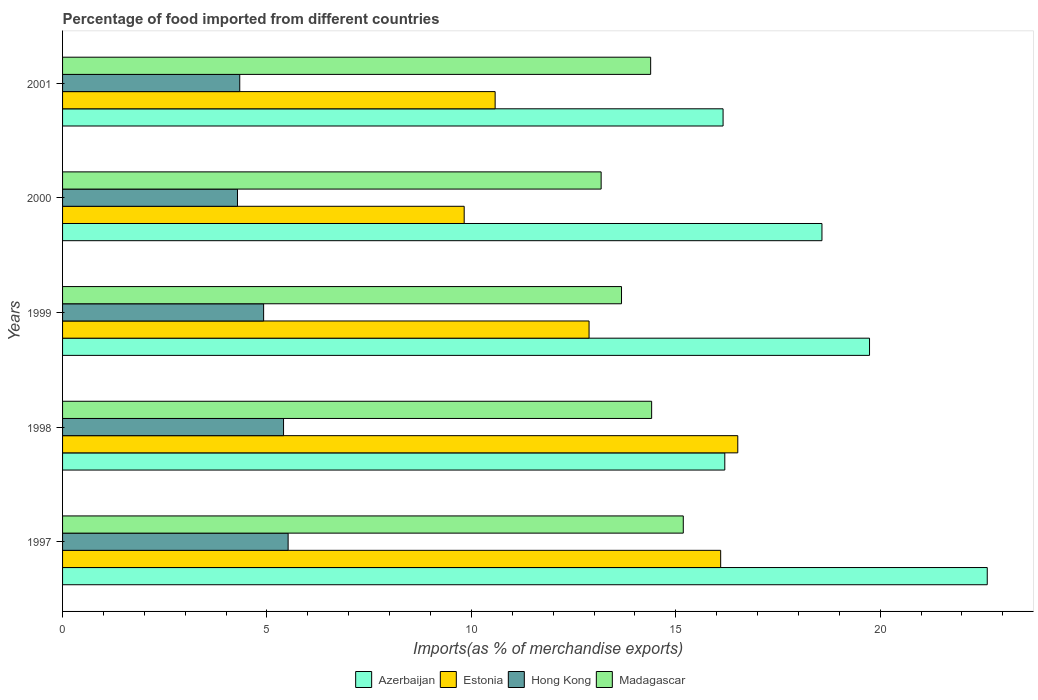How many different coloured bars are there?
Provide a succinct answer. 4. Are the number of bars per tick equal to the number of legend labels?
Give a very brief answer. Yes. Are the number of bars on each tick of the Y-axis equal?
Provide a short and direct response. Yes. How many bars are there on the 5th tick from the bottom?
Provide a succinct answer. 4. What is the label of the 3rd group of bars from the top?
Make the answer very short. 1999. In how many cases, is the number of bars for a given year not equal to the number of legend labels?
Ensure brevity in your answer.  0. What is the percentage of imports to different countries in Hong Kong in 2001?
Ensure brevity in your answer.  4.33. Across all years, what is the maximum percentage of imports to different countries in Estonia?
Offer a very short reply. 16.52. Across all years, what is the minimum percentage of imports to different countries in Madagascar?
Ensure brevity in your answer.  13.17. In which year was the percentage of imports to different countries in Madagascar minimum?
Provide a short and direct response. 2000. What is the total percentage of imports to different countries in Estonia in the graph?
Provide a short and direct response. 65.9. What is the difference between the percentage of imports to different countries in Madagascar in 2000 and that in 2001?
Make the answer very short. -1.21. What is the difference between the percentage of imports to different countries in Estonia in 2000 and the percentage of imports to different countries in Madagascar in 1998?
Offer a terse response. -4.59. What is the average percentage of imports to different countries in Hong Kong per year?
Make the answer very short. 4.89. In the year 1997, what is the difference between the percentage of imports to different countries in Madagascar and percentage of imports to different countries in Estonia?
Your response must be concise. -0.91. What is the ratio of the percentage of imports to different countries in Hong Kong in 1997 to that in 2000?
Ensure brevity in your answer.  1.29. Is the percentage of imports to different countries in Hong Kong in 1998 less than that in 2001?
Provide a short and direct response. No. What is the difference between the highest and the second highest percentage of imports to different countries in Estonia?
Give a very brief answer. 0.42. What is the difference between the highest and the lowest percentage of imports to different countries in Azerbaijan?
Provide a succinct answer. 6.46. In how many years, is the percentage of imports to different countries in Madagascar greater than the average percentage of imports to different countries in Madagascar taken over all years?
Offer a terse response. 3. Is the sum of the percentage of imports to different countries in Estonia in 1998 and 1999 greater than the maximum percentage of imports to different countries in Madagascar across all years?
Ensure brevity in your answer.  Yes. What does the 2nd bar from the top in 2001 represents?
Provide a short and direct response. Hong Kong. What does the 2nd bar from the bottom in 1998 represents?
Offer a very short reply. Estonia. Are the values on the major ticks of X-axis written in scientific E-notation?
Provide a succinct answer. No. Where does the legend appear in the graph?
Your answer should be very brief. Bottom center. What is the title of the graph?
Your response must be concise. Percentage of food imported from different countries. Does "Malta" appear as one of the legend labels in the graph?
Offer a terse response. No. What is the label or title of the X-axis?
Your answer should be compact. Imports(as % of merchandise exports). What is the label or title of the Y-axis?
Provide a short and direct response. Years. What is the Imports(as % of merchandise exports) in Azerbaijan in 1997?
Ensure brevity in your answer.  22.62. What is the Imports(as % of merchandise exports) of Estonia in 1997?
Your response must be concise. 16.1. What is the Imports(as % of merchandise exports) of Hong Kong in 1997?
Ensure brevity in your answer.  5.52. What is the Imports(as % of merchandise exports) of Madagascar in 1997?
Make the answer very short. 15.18. What is the Imports(as % of merchandise exports) in Azerbaijan in 1998?
Make the answer very short. 16.2. What is the Imports(as % of merchandise exports) of Estonia in 1998?
Provide a succinct answer. 16.52. What is the Imports(as % of merchandise exports) of Hong Kong in 1998?
Your answer should be compact. 5.41. What is the Imports(as % of merchandise exports) of Madagascar in 1998?
Make the answer very short. 14.41. What is the Imports(as % of merchandise exports) in Azerbaijan in 1999?
Ensure brevity in your answer.  19.74. What is the Imports(as % of merchandise exports) in Estonia in 1999?
Provide a succinct answer. 12.88. What is the Imports(as % of merchandise exports) in Hong Kong in 1999?
Ensure brevity in your answer.  4.92. What is the Imports(as % of merchandise exports) in Madagascar in 1999?
Provide a succinct answer. 13.67. What is the Imports(as % of merchandise exports) of Azerbaijan in 2000?
Your answer should be very brief. 18.58. What is the Imports(as % of merchandise exports) of Estonia in 2000?
Provide a succinct answer. 9.82. What is the Imports(as % of merchandise exports) in Hong Kong in 2000?
Make the answer very short. 4.28. What is the Imports(as % of merchandise exports) of Madagascar in 2000?
Provide a short and direct response. 13.17. What is the Imports(as % of merchandise exports) in Azerbaijan in 2001?
Keep it short and to the point. 16.16. What is the Imports(as % of merchandise exports) in Estonia in 2001?
Provide a succinct answer. 10.58. What is the Imports(as % of merchandise exports) in Hong Kong in 2001?
Provide a short and direct response. 4.33. What is the Imports(as % of merchandise exports) of Madagascar in 2001?
Provide a short and direct response. 14.39. Across all years, what is the maximum Imports(as % of merchandise exports) of Azerbaijan?
Your response must be concise. 22.62. Across all years, what is the maximum Imports(as % of merchandise exports) in Estonia?
Provide a succinct answer. 16.52. Across all years, what is the maximum Imports(as % of merchandise exports) of Hong Kong?
Offer a very short reply. 5.52. Across all years, what is the maximum Imports(as % of merchandise exports) in Madagascar?
Your response must be concise. 15.18. Across all years, what is the minimum Imports(as % of merchandise exports) in Azerbaijan?
Ensure brevity in your answer.  16.16. Across all years, what is the minimum Imports(as % of merchandise exports) of Estonia?
Offer a very short reply. 9.82. Across all years, what is the minimum Imports(as % of merchandise exports) of Hong Kong?
Offer a terse response. 4.28. Across all years, what is the minimum Imports(as % of merchandise exports) of Madagascar?
Provide a succinct answer. 13.17. What is the total Imports(as % of merchandise exports) of Azerbaijan in the graph?
Your answer should be compact. 93.29. What is the total Imports(as % of merchandise exports) of Estonia in the graph?
Offer a very short reply. 65.9. What is the total Imports(as % of merchandise exports) in Hong Kong in the graph?
Ensure brevity in your answer.  24.45. What is the total Imports(as % of merchandise exports) in Madagascar in the graph?
Your answer should be very brief. 70.83. What is the difference between the Imports(as % of merchandise exports) in Azerbaijan in 1997 and that in 1998?
Provide a succinct answer. 6.42. What is the difference between the Imports(as % of merchandise exports) in Estonia in 1997 and that in 1998?
Give a very brief answer. -0.42. What is the difference between the Imports(as % of merchandise exports) of Hong Kong in 1997 and that in 1998?
Ensure brevity in your answer.  0.11. What is the difference between the Imports(as % of merchandise exports) of Madagascar in 1997 and that in 1998?
Ensure brevity in your answer.  0.77. What is the difference between the Imports(as % of merchandise exports) in Azerbaijan in 1997 and that in 1999?
Your answer should be compact. 2.88. What is the difference between the Imports(as % of merchandise exports) in Estonia in 1997 and that in 1999?
Give a very brief answer. 3.22. What is the difference between the Imports(as % of merchandise exports) in Hong Kong in 1997 and that in 1999?
Your answer should be very brief. 0.6. What is the difference between the Imports(as % of merchandise exports) of Madagascar in 1997 and that in 1999?
Provide a short and direct response. 1.51. What is the difference between the Imports(as % of merchandise exports) of Azerbaijan in 1997 and that in 2000?
Provide a succinct answer. 4.04. What is the difference between the Imports(as % of merchandise exports) in Estonia in 1997 and that in 2000?
Your answer should be compact. 6.27. What is the difference between the Imports(as % of merchandise exports) of Hong Kong in 1997 and that in 2000?
Keep it short and to the point. 1.24. What is the difference between the Imports(as % of merchandise exports) in Madagascar in 1997 and that in 2000?
Offer a terse response. 2.01. What is the difference between the Imports(as % of merchandise exports) in Azerbaijan in 1997 and that in 2001?
Your response must be concise. 6.46. What is the difference between the Imports(as % of merchandise exports) in Estonia in 1997 and that in 2001?
Your response must be concise. 5.52. What is the difference between the Imports(as % of merchandise exports) in Hong Kong in 1997 and that in 2001?
Offer a very short reply. 1.18. What is the difference between the Imports(as % of merchandise exports) in Madagascar in 1997 and that in 2001?
Your response must be concise. 0.8. What is the difference between the Imports(as % of merchandise exports) of Azerbaijan in 1998 and that in 1999?
Provide a short and direct response. -3.54. What is the difference between the Imports(as % of merchandise exports) of Estonia in 1998 and that in 1999?
Your answer should be compact. 3.64. What is the difference between the Imports(as % of merchandise exports) in Hong Kong in 1998 and that in 1999?
Provide a short and direct response. 0.49. What is the difference between the Imports(as % of merchandise exports) of Madagascar in 1998 and that in 1999?
Make the answer very short. 0.74. What is the difference between the Imports(as % of merchandise exports) of Azerbaijan in 1998 and that in 2000?
Keep it short and to the point. -2.38. What is the difference between the Imports(as % of merchandise exports) in Estonia in 1998 and that in 2000?
Your answer should be compact. 6.69. What is the difference between the Imports(as % of merchandise exports) of Hong Kong in 1998 and that in 2000?
Your answer should be compact. 1.13. What is the difference between the Imports(as % of merchandise exports) of Madagascar in 1998 and that in 2000?
Offer a very short reply. 1.24. What is the difference between the Imports(as % of merchandise exports) in Azerbaijan in 1998 and that in 2001?
Your answer should be very brief. 0.04. What is the difference between the Imports(as % of merchandise exports) in Estonia in 1998 and that in 2001?
Provide a short and direct response. 5.94. What is the difference between the Imports(as % of merchandise exports) in Hong Kong in 1998 and that in 2001?
Your answer should be very brief. 1.07. What is the difference between the Imports(as % of merchandise exports) in Madagascar in 1998 and that in 2001?
Provide a short and direct response. 0.02. What is the difference between the Imports(as % of merchandise exports) in Azerbaijan in 1999 and that in 2000?
Provide a succinct answer. 1.16. What is the difference between the Imports(as % of merchandise exports) of Estonia in 1999 and that in 2000?
Your answer should be very brief. 3.05. What is the difference between the Imports(as % of merchandise exports) of Hong Kong in 1999 and that in 2000?
Provide a short and direct response. 0.64. What is the difference between the Imports(as % of merchandise exports) of Madagascar in 1999 and that in 2000?
Offer a very short reply. 0.5. What is the difference between the Imports(as % of merchandise exports) in Azerbaijan in 1999 and that in 2001?
Ensure brevity in your answer.  3.58. What is the difference between the Imports(as % of merchandise exports) of Estonia in 1999 and that in 2001?
Keep it short and to the point. 2.3. What is the difference between the Imports(as % of merchandise exports) in Hong Kong in 1999 and that in 2001?
Give a very brief answer. 0.58. What is the difference between the Imports(as % of merchandise exports) of Madagascar in 1999 and that in 2001?
Keep it short and to the point. -0.71. What is the difference between the Imports(as % of merchandise exports) of Azerbaijan in 2000 and that in 2001?
Your answer should be very brief. 2.42. What is the difference between the Imports(as % of merchandise exports) of Estonia in 2000 and that in 2001?
Ensure brevity in your answer.  -0.76. What is the difference between the Imports(as % of merchandise exports) in Hong Kong in 2000 and that in 2001?
Ensure brevity in your answer.  -0.06. What is the difference between the Imports(as % of merchandise exports) of Madagascar in 2000 and that in 2001?
Offer a very short reply. -1.21. What is the difference between the Imports(as % of merchandise exports) in Azerbaijan in 1997 and the Imports(as % of merchandise exports) in Estonia in 1998?
Provide a succinct answer. 6.1. What is the difference between the Imports(as % of merchandise exports) in Azerbaijan in 1997 and the Imports(as % of merchandise exports) in Hong Kong in 1998?
Offer a terse response. 17.21. What is the difference between the Imports(as % of merchandise exports) in Azerbaijan in 1997 and the Imports(as % of merchandise exports) in Madagascar in 1998?
Give a very brief answer. 8.21. What is the difference between the Imports(as % of merchandise exports) of Estonia in 1997 and the Imports(as % of merchandise exports) of Hong Kong in 1998?
Give a very brief answer. 10.69. What is the difference between the Imports(as % of merchandise exports) of Estonia in 1997 and the Imports(as % of merchandise exports) of Madagascar in 1998?
Offer a terse response. 1.69. What is the difference between the Imports(as % of merchandise exports) of Hong Kong in 1997 and the Imports(as % of merchandise exports) of Madagascar in 1998?
Provide a short and direct response. -8.89. What is the difference between the Imports(as % of merchandise exports) in Azerbaijan in 1997 and the Imports(as % of merchandise exports) in Estonia in 1999?
Your answer should be compact. 9.74. What is the difference between the Imports(as % of merchandise exports) of Azerbaijan in 1997 and the Imports(as % of merchandise exports) of Hong Kong in 1999?
Keep it short and to the point. 17.7. What is the difference between the Imports(as % of merchandise exports) of Azerbaijan in 1997 and the Imports(as % of merchandise exports) of Madagascar in 1999?
Give a very brief answer. 8.95. What is the difference between the Imports(as % of merchandise exports) in Estonia in 1997 and the Imports(as % of merchandise exports) in Hong Kong in 1999?
Offer a terse response. 11.18. What is the difference between the Imports(as % of merchandise exports) in Estonia in 1997 and the Imports(as % of merchandise exports) in Madagascar in 1999?
Your response must be concise. 2.43. What is the difference between the Imports(as % of merchandise exports) of Hong Kong in 1997 and the Imports(as % of merchandise exports) of Madagascar in 1999?
Your answer should be very brief. -8.16. What is the difference between the Imports(as % of merchandise exports) of Azerbaijan in 1997 and the Imports(as % of merchandise exports) of Estonia in 2000?
Your response must be concise. 12.8. What is the difference between the Imports(as % of merchandise exports) in Azerbaijan in 1997 and the Imports(as % of merchandise exports) in Hong Kong in 2000?
Your response must be concise. 18.34. What is the difference between the Imports(as % of merchandise exports) of Azerbaijan in 1997 and the Imports(as % of merchandise exports) of Madagascar in 2000?
Provide a short and direct response. 9.45. What is the difference between the Imports(as % of merchandise exports) of Estonia in 1997 and the Imports(as % of merchandise exports) of Hong Kong in 2000?
Your answer should be compact. 11.82. What is the difference between the Imports(as % of merchandise exports) in Estonia in 1997 and the Imports(as % of merchandise exports) in Madagascar in 2000?
Provide a short and direct response. 2.92. What is the difference between the Imports(as % of merchandise exports) in Hong Kong in 1997 and the Imports(as % of merchandise exports) in Madagascar in 2000?
Ensure brevity in your answer.  -7.66. What is the difference between the Imports(as % of merchandise exports) in Azerbaijan in 1997 and the Imports(as % of merchandise exports) in Estonia in 2001?
Keep it short and to the point. 12.04. What is the difference between the Imports(as % of merchandise exports) in Azerbaijan in 1997 and the Imports(as % of merchandise exports) in Hong Kong in 2001?
Your answer should be very brief. 18.29. What is the difference between the Imports(as % of merchandise exports) of Azerbaijan in 1997 and the Imports(as % of merchandise exports) of Madagascar in 2001?
Provide a succinct answer. 8.23. What is the difference between the Imports(as % of merchandise exports) of Estonia in 1997 and the Imports(as % of merchandise exports) of Hong Kong in 2001?
Provide a succinct answer. 11.76. What is the difference between the Imports(as % of merchandise exports) in Estonia in 1997 and the Imports(as % of merchandise exports) in Madagascar in 2001?
Your response must be concise. 1.71. What is the difference between the Imports(as % of merchandise exports) in Hong Kong in 1997 and the Imports(as % of merchandise exports) in Madagascar in 2001?
Provide a succinct answer. -8.87. What is the difference between the Imports(as % of merchandise exports) in Azerbaijan in 1998 and the Imports(as % of merchandise exports) in Estonia in 1999?
Ensure brevity in your answer.  3.32. What is the difference between the Imports(as % of merchandise exports) of Azerbaijan in 1998 and the Imports(as % of merchandise exports) of Hong Kong in 1999?
Ensure brevity in your answer.  11.28. What is the difference between the Imports(as % of merchandise exports) in Azerbaijan in 1998 and the Imports(as % of merchandise exports) in Madagascar in 1999?
Ensure brevity in your answer.  2.53. What is the difference between the Imports(as % of merchandise exports) of Estonia in 1998 and the Imports(as % of merchandise exports) of Hong Kong in 1999?
Offer a very short reply. 11.6. What is the difference between the Imports(as % of merchandise exports) of Estonia in 1998 and the Imports(as % of merchandise exports) of Madagascar in 1999?
Keep it short and to the point. 2.84. What is the difference between the Imports(as % of merchandise exports) in Hong Kong in 1998 and the Imports(as % of merchandise exports) in Madagascar in 1999?
Provide a succinct answer. -8.27. What is the difference between the Imports(as % of merchandise exports) of Azerbaijan in 1998 and the Imports(as % of merchandise exports) of Estonia in 2000?
Offer a terse response. 6.37. What is the difference between the Imports(as % of merchandise exports) of Azerbaijan in 1998 and the Imports(as % of merchandise exports) of Hong Kong in 2000?
Provide a succinct answer. 11.92. What is the difference between the Imports(as % of merchandise exports) of Azerbaijan in 1998 and the Imports(as % of merchandise exports) of Madagascar in 2000?
Offer a very short reply. 3.02. What is the difference between the Imports(as % of merchandise exports) in Estonia in 1998 and the Imports(as % of merchandise exports) in Hong Kong in 2000?
Keep it short and to the point. 12.24. What is the difference between the Imports(as % of merchandise exports) in Estonia in 1998 and the Imports(as % of merchandise exports) in Madagascar in 2000?
Keep it short and to the point. 3.34. What is the difference between the Imports(as % of merchandise exports) in Hong Kong in 1998 and the Imports(as % of merchandise exports) in Madagascar in 2000?
Your response must be concise. -7.77. What is the difference between the Imports(as % of merchandise exports) of Azerbaijan in 1998 and the Imports(as % of merchandise exports) of Estonia in 2001?
Provide a succinct answer. 5.62. What is the difference between the Imports(as % of merchandise exports) in Azerbaijan in 1998 and the Imports(as % of merchandise exports) in Hong Kong in 2001?
Offer a terse response. 11.86. What is the difference between the Imports(as % of merchandise exports) in Azerbaijan in 1998 and the Imports(as % of merchandise exports) in Madagascar in 2001?
Offer a very short reply. 1.81. What is the difference between the Imports(as % of merchandise exports) in Estonia in 1998 and the Imports(as % of merchandise exports) in Hong Kong in 2001?
Provide a short and direct response. 12.18. What is the difference between the Imports(as % of merchandise exports) in Estonia in 1998 and the Imports(as % of merchandise exports) in Madagascar in 2001?
Keep it short and to the point. 2.13. What is the difference between the Imports(as % of merchandise exports) of Hong Kong in 1998 and the Imports(as % of merchandise exports) of Madagascar in 2001?
Your response must be concise. -8.98. What is the difference between the Imports(as % of merchandise exports) in Azerbaijan in 1999 and the Imports(as % of merchandise exports) in Estonia in 2000?
Offer a very short reply. 9.92. What is the difference between the Imports(as % of merchandise exports) in Azerbaijan in 1999 and the Imports(as % of merchandise exports) in Hong Kong in 2000?
Your response must be concise. 15.46. What is the difference between the Imports(as % of merchandise exports) of Azerbaijan in 1999 and the Imports(as % of merchandise exports) of Madagascar in 2000?
Your response must be concise. 6.57. What is the difference between the Imports(as % of merchandise exports) in Estonia in 1999 and the Imports(as % of merchandise exports) in Hong Kong in 2000?
Provide a short and direct response. 8.6. What is the difference between the Imports(as % of merchandise exports) of Estonia in 1999 and the Imports(as % of merchandise exports) of Madagascar in 2000?
Offer a terse response. -0.3. What is the difference between the Imports(as % of merchandise exports) of Hong Kong in 1999 and the Imports(as % of merchandise exports) of Madagascar in 2000?
Provide a succinct answer. -8.26. What is the difference between the Imports(as % of merchandise exports) of Azerbaijan in 1999 and the Imports(as % of merchandise exports) of Estonia in 2001?
Offer a very short reply. 9.16. What is the difference between the Imports(as % of merchandise exports) of Azerbaijan in 1999 and the Imports(as % of merchandise exports) of Hong Kong in 2001?
Make the answer very short. 15.41. What is the difference between the Imports(as % of merchandise exports) of Azerbaijan in 1999 and the Imports(as % of merchandise exports) of Madagascar in 2001?
Offer a terse response. 5.35. What is the difference between the Imports(as % of merchandise exports) of Estonia in 1999 and the Imports(as % of merchandise exports) of Hong Kong in 2001?
Your answer should be very brief. 8.54. What is the difference between the Imports(as % of merchandise exports) of Estonia in 1999 and the Imports(as % of merchandise exports) of Madagascar in 2001?
Your answer should be compact. -1.51. What is the difference between the Imports(as % of merchandise exports) of Hong Kong in 1999 and the Imports(as % of merchandise exports) of Madagascar in 2001?
Your answer should be compact. -9.47. What is the difference between the Imports(as % of merchandise exports) of Azerbaijan in 2000 and the Imports(as % of merchandise exports) of Estonia in 2001?
Make the answer very short. 7.99. What is the difference between the Imports(as % of merchandise exports) of Azerbaijan in 2000 and the Imports(as % of merchandise exports) of Hong Kong in 2001?
Give a very brief answer. 14.24. What is the difference between the Imports(as % of merchandise exports) of Azerbaijan in 2000 and the Imports(as % of merchandise exports) of Madagascar in 2001?
Make the answer very short. 4.19. What is the difference between the Imports(as % of merchandise exports) of Estonia in 2000 and the Imports(as % of merchandise exports) of Hong Kong in 2001?
Offer a very short reply. 5.49. What is the difference between the Imports(as % of merchandise exports) in Estonia in 2000 and the Imports(as % of merchandise exports) in Madagascar in 2001?
Make the answer very short. -4.56. What is the difference between the Imports(as % of merchandise exports) in Hong Kong in 2000 and the Imports(as % of merchandise exports) in Madagascar in 2001?
Offer a very short reply. -10.11. What is the average Imports(as % of merchandise exports) in Azerbaijan per year?
Your response must be concise. 18.66. What is the average Imports(as % of merchandise exports) in Estonia per year?
Provide a short and direct response. 13.18. What is the average Imports(as % of merchandise exports) of Hong Kong per year?
Provide a succinct answer. 4.89. What is the average Imports(as % of merchandise exports) of Madagascar per year?
Your answer should be compact. 14.17. In the year 1997, what is the difference between the Imports(as % of merchandise exports) in Azerbaijan and Imports(as % of merchandise exports) in Estonia?
Your response must be concise. 6.52. In the year 1997, what is the difference between the Imports(as % of merchandise exports) in Azerbaijan and Imports(as % of merchandise exports) in Hong Kong?
Make the answer very short. 17.1. In the year 1997, what is the difference between the Imports(as % of merchandise exports) in Azerbaijan and Imports(as % of merchandise exports) in Madagascar?
Ensure brevity in your answer.  7.44. In the year 1997, what is the difference between the Imports(as % of merchandise exports) in Estonia and Imports(as % of merchandise exports) in Hong Kong?
Your answer should be compact. 10.58. In the year 1997, what is the difference between the Imports(as % of merchandise exports) in Estonia and Imports(as % of merchandise exports) in Madagascar?
Your answer should be compact. 0.91. In the year 1997, what is the difference between the Imports(as % of merchandise exports) in Hong Kong and Imports(as % of merchandise exports) in Madagascar?
Provide a succinct answer. -9.67. In the year 1998, what is the difference between the Imports(as % of merchandise exports) of Azerbaijan and Imports(as % of merchandise exports) of Estonia?
Your answer should be very brief. -0.32. In the year 1998, what is the difference between the Imports(as % of merchandise exports) of Azerbaijan and Imports(as % of merchandise exports) of Hong Kong?
Offer a terse response. 10.79. In the year 1998, what is the difference between the Imports(as % of merchandise exports) of Azerbaijan and Imports(as % of merchandise exports) of Madagascar?
Give a very brief answer. 1.79. In the year 1998, what is the difference between the Imports(as % of merchandise exports) in Estonia and Imports(as % of merchandise exports) in Hong Kong?
Your answer should be compact. 11.11. In the year 1998, what is the difference between the Imports(as % of merchandise exports) of Estonia and Imports(as % of merchandise exports) of Madagascar?
Ensure brevity in your answer.  2.11. In the year 1998, what is the difference between the Imports(as % of merchandise exports) of Hong Kong and Imports(as % of merchandise exports) of Madagascar?
Make the answer very short. -9. In the year 1999, what is the difference between the Imports(as % of merchandise exports) of Azerbaijan and Imports(as % of merchandise exports) of Estonia?
Your response must be concise. 6.86. In the year 1999, what is the difference between the Imports(as % of merchandise exports) of Azerbaijan and Imports(as % of merchandise exports) of Hong Kong?
Provide a short and direct response. 14.82. In the year 1999, what is the difference between the Imports(as % of merchandise exports) in Azerbaijan and Imports(as % of merchandise exports) in Madagascar?
Keep it short and to the point. 6.07. In the year 1999, what is the difference between the Imports(as % of merchandise exports) of Estonia and Imports(as % of merchandise exports) of Hong Kong?
Provide a succinct answer. 7.96. In the year 1999, what is the difference between the Imports(as % of merchandise exports) in Estonia and Imports(as % of merchandise exports) in Madagascar?
Your response must be concise. -0.79. In the year 1999, what is the difference between the Imports(as % of merchandise exports) of Hong Kong and Imports(as % of merchandise exports) of Madagascar?
Make the answer very short. -8.75. In the year 2000, what is the difference between the Imports(as % of merchandise exports) in Azerbaijan and Imports(as % of merchandise exports) in Estonia?
Provide a short and direct response. 8.75. In the year 2000, what is the difference between the Imports(as % of merchandise exports) of Azerbaijan and Imports(as % of merchandise exports) of Hong Kong?
Keep it short and to the point. 14.3. In the year 2000, what is the difference between the Imports(as % of merchandise exports) of Azerbaijan and Imports(as % of merchandise exports) of Madagascar?
Your answer should be very brief. 5.4. In the year 2000, what is the difference between the Imports(as % of merchandise exports) in Estonia and Imports(as % of merchandise exports) in Hong Kong?
Offer a terse response. 5.55. In the year 2000, what is the difference between the Imports(as % of merchandise exports) of Estonia and Imports(as % of merchandise exports) of Madagascar?
Offer a very short reply. -3.35. In the year 2000, what is the difference between the Imports(as % of merchandise exports) of Hong Kong and Imports(as % of merchandise exports) of Madagascar?
Offer a very short reply. -8.9. In the year 2001, what is the difference between the Imports(as % of merchandise exports) of Azerbaijan and Imports(as % of merchandise exports) of Estonia?
Offer a terse response. 5.58. In the year 2001, what is the difference between the Imports(as % of merchandise exports) of Azerbaijan and Imports(as % of merchandise exports) of Hong Kong?
Keep it short and to the point. 11.82. In the year 2001, what is the difference between the Imports(as % of merchandise exports) of Azerbaijan and Imports(as % of merchandise exports) of Madagascar?
Provide a short and direct response. 1.77. In the year 2001, what is the difference between the Imports(as % of merchandise exports) in Estonia and Imports(as % of merchandise exports) in Hong Kong?
Keep it short and to the point. 6.25. In the year 2001, what is the difference between the Imports(as % of merchandise exports) in Estonia and Imports(as % of merchandise exports) in Madagascar?
Ensure brevity in your answer.  -3.8. In the year 2001, what is the difference between the Imports(as % of merchandise exports) of Hong Kong and Imports(as % of merchandise exports) of Madagascar?
Your answer should be very brief. -10.05. What is the ratio of the Imports(as % of merchandise exports) in Azerbaijan in 1997 to that in 1998?
Your answer should be very brief. 1.4. What is the ratio of the Imports(as % of merchandise exports) of Estonia in 1997 to that in 1998?
Your answer should be compact. 0.97. What is the ratio of the Imports(as % of merchandise exports) in Hong Kong in 1997 to that in 1998?
Keep it short and to the point. 1.02. What is the ratio of the Imports(as % of merchandise exports) in Madagascar in 1997 to that in 1998?
Make the answer very short. 1.05. What is the ratio of the Imports(as % of merchandise exports) of Azerbaijan in 1997 to that in 1999?
Offer a very short reply. 1.15. What is the ratio of the Imports(as % of merchandise exports) of Estonia in 1997 to that in 1999?
Your answer should be compact. 1.25. What is the ratio of the Imports(as % of merchandise exports) of Hong Kong in 1997 to that in 1999?
Keep it short and to the point. 1.12. What is the ratio of the Imports(as % of merchandise exports) of Madagascar in 1997 to that in 1999?
Provide a succinct answer. 1.11. What is the ratio of the Imports(as % of merchandise exports) of Azerbaijan in 1997 to that in 2000?
Keep it short and to the point. 1.22. What is the ratio of the Imports(as % of merchandise exports) in Estonia in 1997 to that in 2000?
Give a very brief answer. 1.64. What is the ratio of the Imports(as % of merchandise exports) in Hong Kong in 1997 to that in 2000?
Keep it short and to the point. 1.29. What is the ratio of the Imports(as % of merchandise exports) of Madagascar in 1997 to that in 2000?
Provide a short and direct response. 1.15. What is the ratio of the Imports(as % of merchandise exports) of Estonia in 1997 to that in 2001?
Offer a very short reply. 1.52. What is the ratio of the Imports(as % of merchandise exports) of Hong Kong in 1997 to that in 2001?
Ensure brevity in your answer.  1.27. What is the ratio of the Imports(as % of merchandise exports) of Madagascar in 1997 to that in 2001?
Ensure brevity in your answer.  1.06. What is the ratio of the Imports(as % of merchandise exports) of Azerbaijan in 1998 to that in 1999?
Offer a terse response. 0.82. What is the ratio of the Imports(as % of merchandise exports) of Estonia in 1998 to that in 1999?
Your answer should be very brief. 1.28. What is the ratio of the Imports(as % of merchandise exports) of Hong Kong in 1998 to that in 1999?
Offer a terse response. 1.1. What is the ratio of the Imports(as % of merchandise exports) of Madagascar in 1998 to that in 1999?
Offer a terse response. 1.05. What is the ratio of the Imports(as % of merchandise exports) of Azerbaijan in 1998 to that in 2000?
Your response must be concise. 0.87. What is the ratio of the Imports(as % of merchandise exports) of Estonia in 1998 to that in 2000?
Provide a succinct answer. 1.68. What is the ratio of the Imports(as % of merchandise exports) of Hong Kong in 1998 to that in 2000?
Your response must be concise. 1.26. What is the ratio of the Imports(as % of merchandise exports) in Madagascar in 1998 to that in 2000?
Offer a very short reply. 1.09. What is the ratio of the Imports(as % of merchandise exports) in Azerbaijan in 1998 to that in 2001?
Your answer should be very brief. 1. What is the ratio of the Imports(as % of merchandise exports) of Estonia in 1998 to that in 2001?
Your answer should be very brief. 1.56. What is the ratio of the Imports(as % of merchandise exports) of Hong Kong in 1998 to that in 2001?
Make the answer very short. 1.25. What is the ratio of the Imports(as % of merchandise exports) of Azerbaijan in 1999 to that in 2000?
Offer a terse response. 1.06. What is the ratio of the Imports(as % of merchandise exports) in Estonia in 1999 to that in 2000?
Your answer should be very brief. 1.31. What is the ratio of the Imports(as % of merchandise exports) in Hong Kong in 1999 to that in 2000?
Ensure brevity in your answer.  1.15. What is the ratio of the Imports(as % of merchandise exports) of Madagascar in 1999 to that in 2000?
Your answer should be compact. 1.04. What is the ratio of the Imports(as % of merchandise exports) in Azerbaijan in 1999 to that in 2001?
Provide a short and direct response. 1.22. What is the ratio of the Imports(as % of merchandise exports) in Estonia in 1999 to that in 2001?
Your answer should be very brief. 1.22. What is the ratio of the Imports(as % of merchandise exports) in Hong Kong in 1999 to that in 2001?
Provide a short and direct response. 1.13. What is the ratio of the Imports(as % of merchandise exports) in Madagascar in 1999 to that in 2001?
Make the answer very short. 0.95. What is the ratio of the Imports(as % of merchandise exports) of Azerbaijan in 2000 to that in 2001?
Provide a succinct answer. 1.15. What is the ratio of the Imports(as % of merchandise exports) of Estonia in 2000 to that in 2001?
Ensure brevity in your answer.  0.93. What is the ratio of the Imports(as % of merchandise exports) in Hong Kong in 2000 to that in 2001?
Offer a terse response. 0.99. What is the ratio of the Imports(as % of merchandise exports) of Madagascar in 2000 to that in 2001?
Make the answer very short. 0.92. What is the difference between the highest and the second highest Imports(as % of merchandise exports) of Azerbaijan?
Make the answer very short. 2.88. What is the difference between the highest and the second highest Imports(as % of merchandise exports) in Estonia?
Provide a short and direct response. 0.42. What is the difference between the highest and the second highest Imports(as % of merchandise exports) of Hong Kong?
Your response must be concise. 0.11. What is the difference between the highest and the second highest Imports(as % of merchandise exports) in Madagascar?
Offer a terse response. 0.77. What is the difference between the highest and the lowest Imports(as % of merchandise exports) of Azerbaijan?
Make the answer very short. 6.46. What is the difference between the highest and the lowest Imports(as % of merchandise exports) in Estonia?
Make the answer very short. 6.69. What is the difference between the highest and the lowest Imports(as % of merchandise exports) of Hong Kong?
Your answer should be compact. 1.24. What is the difference between the highest and the lowest Imports(as % of merchandise exports) of Madagascar?
Provide a short and direct response. 2.01. 